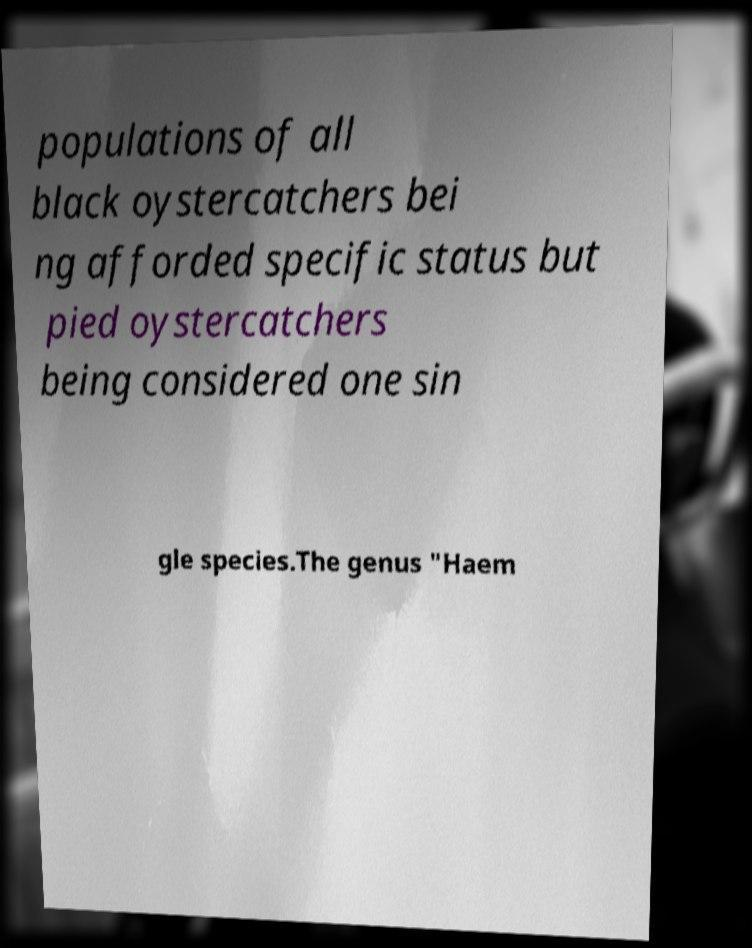Please identify and transcribe the text found in this image. populations of all black oystercatchers bei ng afforded specific status but pied oystercatchers being considered one sin gle species.The genus "Haem 